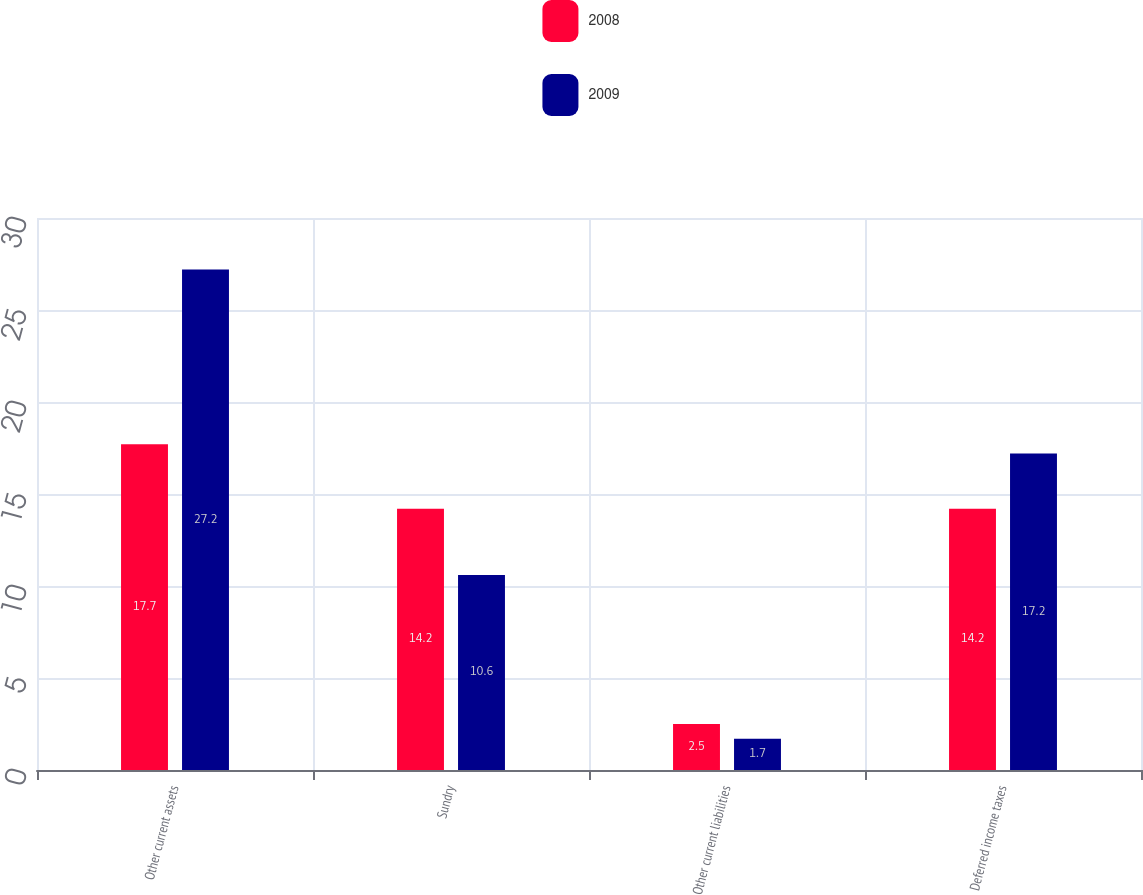Convert chart to OTSL. <chart><loc_0><loc_0><loc_500><loc_500><stacked_bar_chart><ecel><fcel>Other current assets<fcel>Sundry<fcel>Other current liabilities<fcel>Deferred income taxes<nl><fcel>2008<fcel>17.7<fcel>14.2<fcel>2.5<fcel>14.2<nl><fcel>2009<fcel>27.2<fcel>10.6<fcel>1.7<fcel>17.2<nl></chart> 